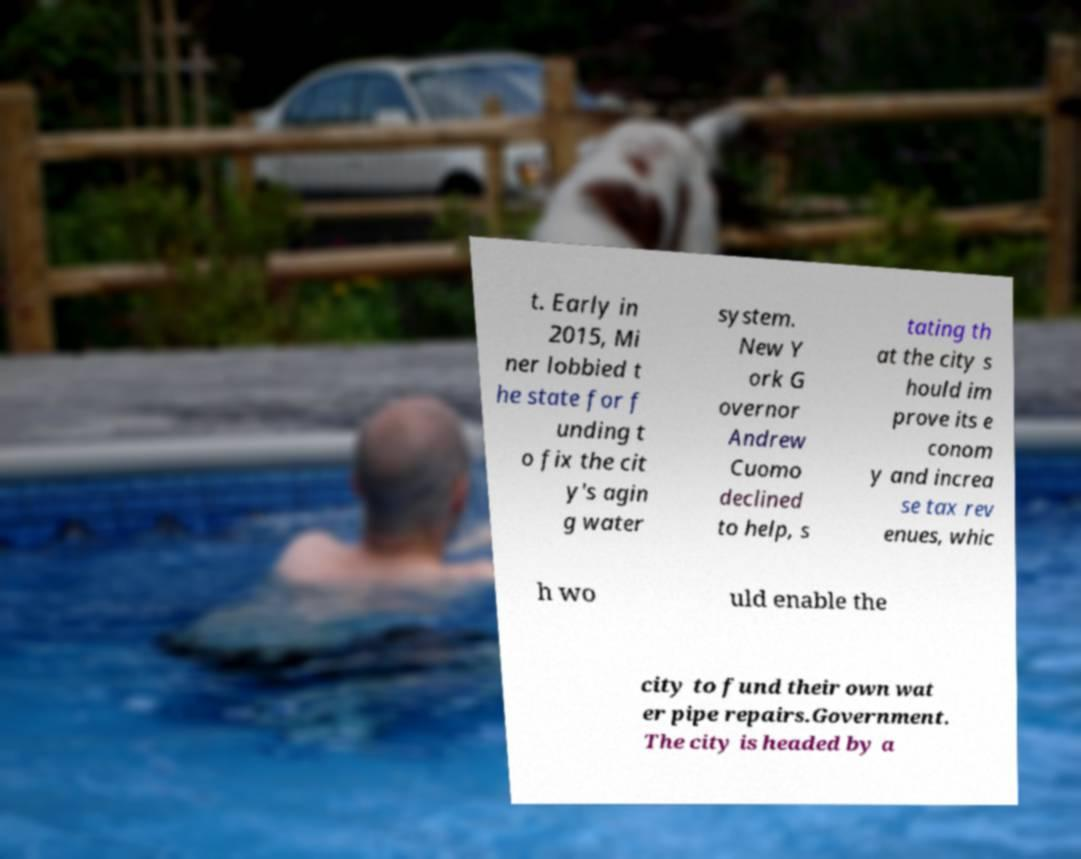Can you accurately transcribe the text from the provided image for me? t. Early in 2015, Mi ner lobbied t he state for f unding t o fix the cit y's agin g water system. New Y ork G overnor Andrew Cuomo declined to help, s tating th at the city s hould im prove its e conom y and increa se tax rev enues, whic h wo uld enable the city to fund their own wat er pipe repairs.Government. The city is headed by a 